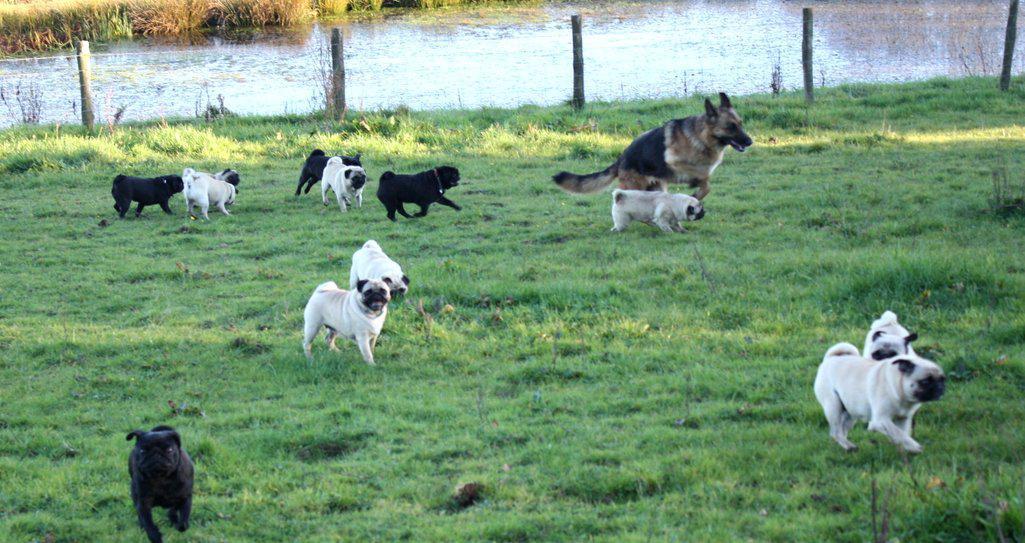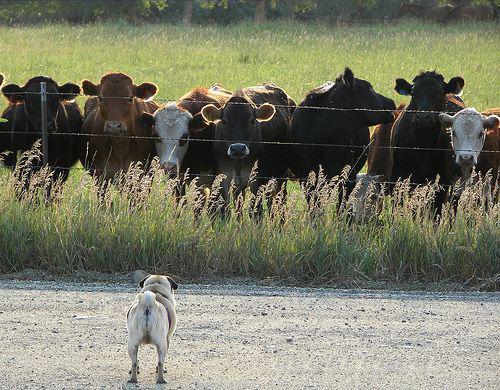The first image is the image on the left, the second image is the image on the right. Assess this claim about the two images: "A person is standing in one of the images.". Correct or not? Answer yes or no. No. 